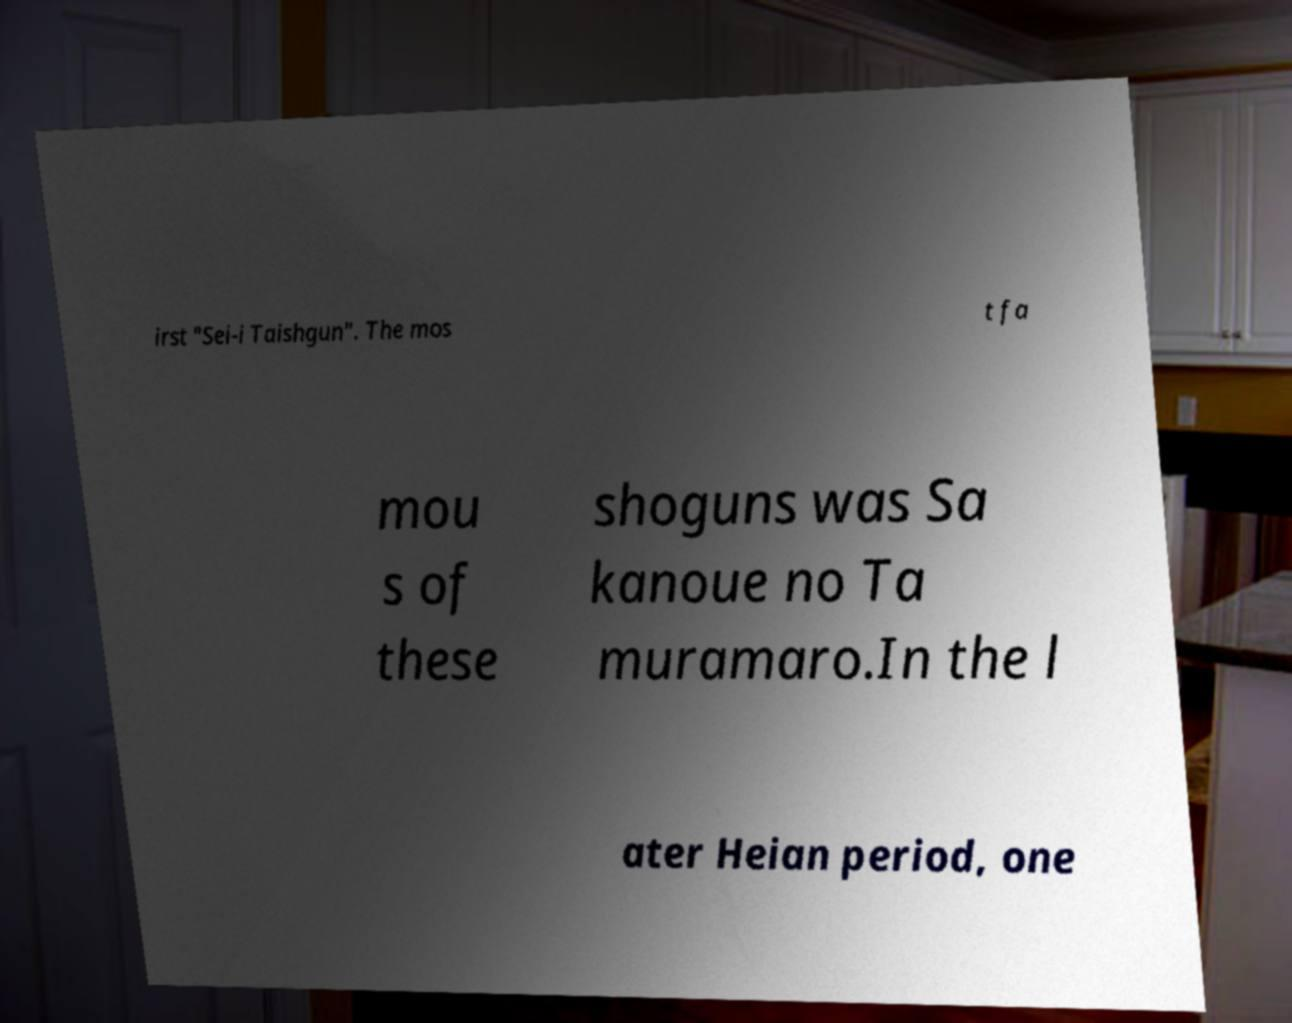For documentation purposes, I need the text within this image transcribed. Could you provide that? irst "Sei-i Taishgun". The mos t fa mou s of these shoguns was Sa kanoue no Ta muramaro.In the l ater Heian period, one 